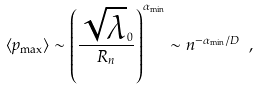Convert formula to latex. <formula><loc_0><loc_0><loc_500><loc_500>\langle p _ { \max } \rangle \sim \left ( \frac { \sqrt { \lambda } _ { 0 } } { R _ { n } } \right ) ^ { \alpha _ { \min } } \sim n ^ { - \alpha _ { \min } / D } \ ,</formula> 